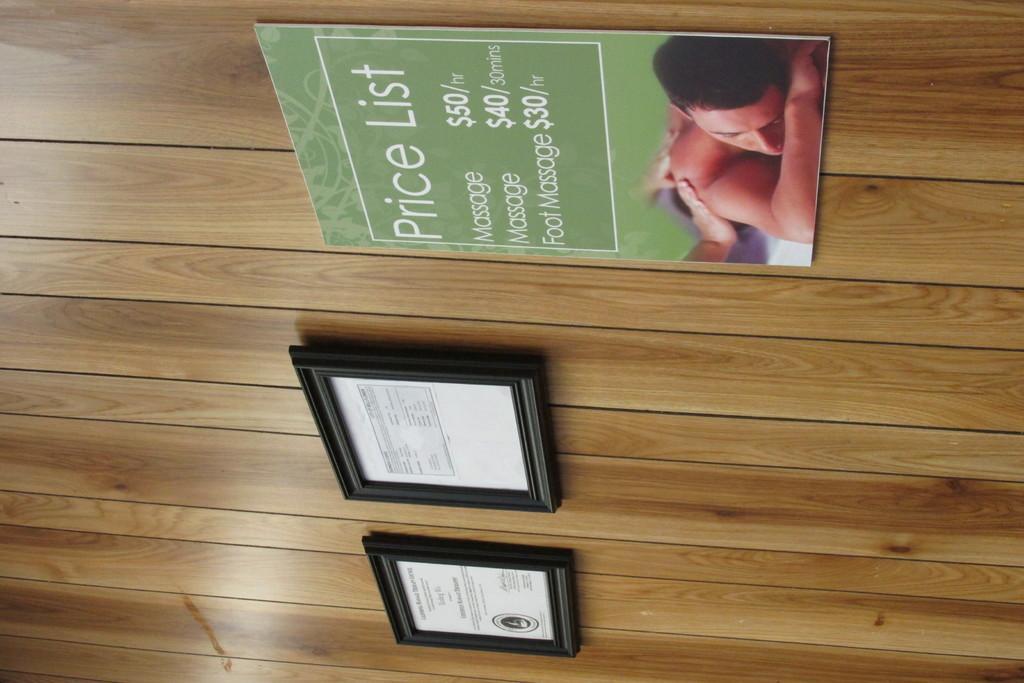Could you give a brief overview of what you see in this image? In this picture we can see certificates frames, poster on a wooden wall and this poster we can see a person and some text on it. 